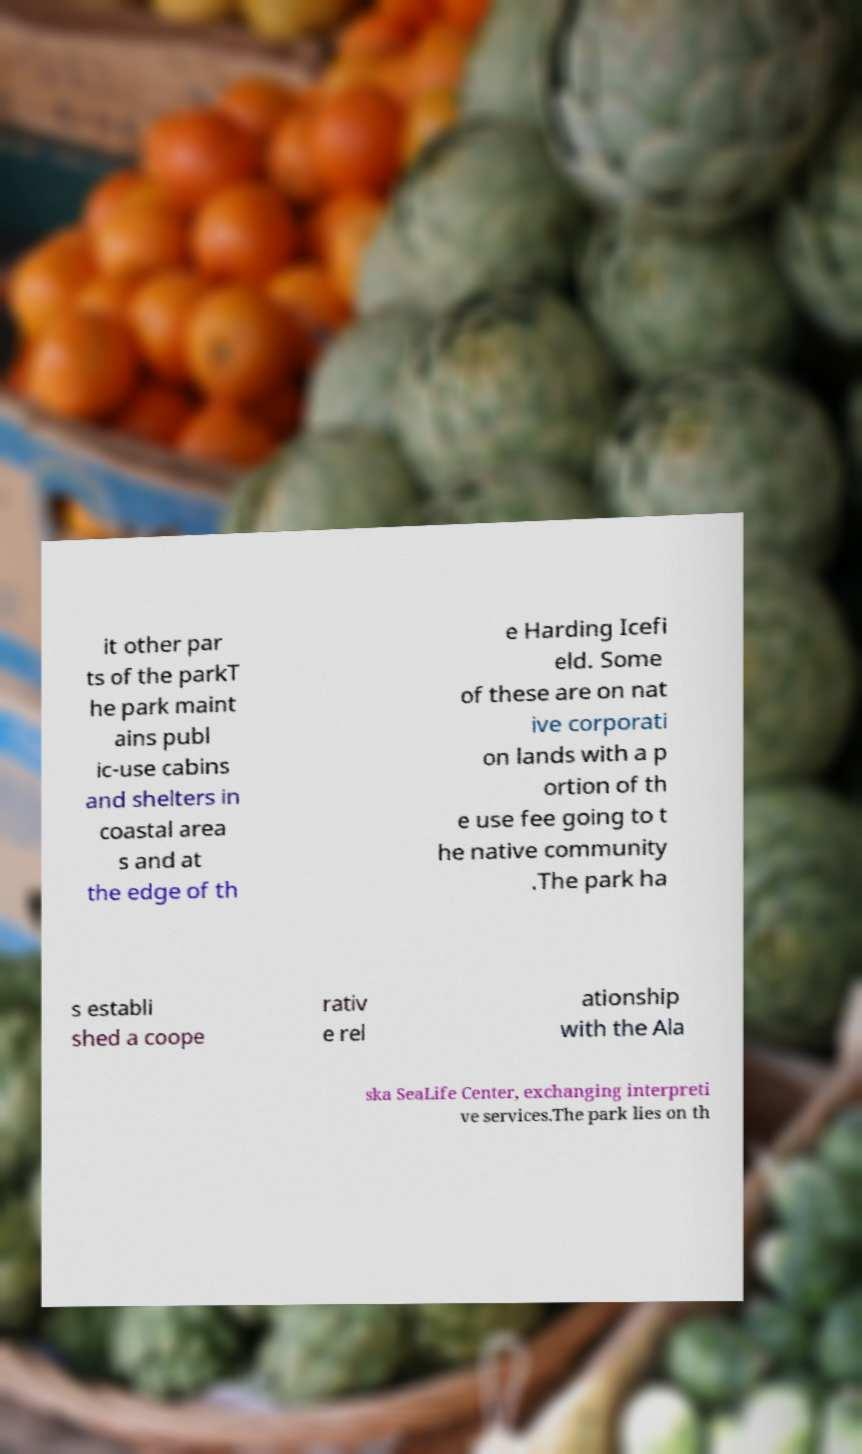Could you extract and type out the text from this image? it other par ts of the parkT he park maint ains publ ic-use cabins and shelters in coastal area s and at the edge of th e Harding Icefi eld. Some of these are on nat ive corporati on lands with a p ortion of th e use fee going to t he native community .The park ha s establi shed a coope rativ e rel ationship with the Ala ska SeaLife Center, exchanging interpreti ve services.The park lies on th 